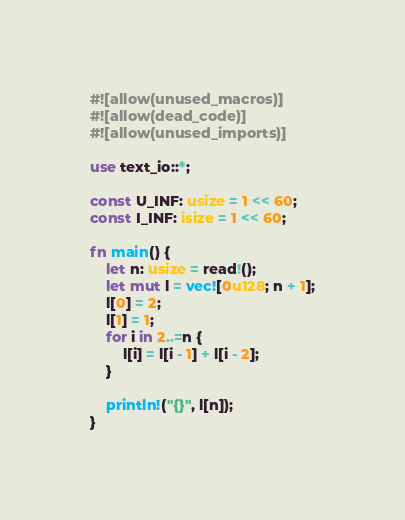Convert code to text. <code><loc_0><loc_0><loc_500><loc_500><_Rust_>#![allow(unused_macros)]
#![allow(dead_code)]
#![allow(unused_imports)]

use text_io::*;

const U_INF: usize = 1 << 60;
const I_INF: isize = 1 << 60;

fn main() {
    let n: usize = read!();
    let mut l = vec![0u128; n + 1];
    l[0] = 2;
    l[1] = 1;
    for i in 2..=n {
        l[i] = l[i - 1] + l[i - 2];
    }

    println!("{}", l[n]);
}
</code> 